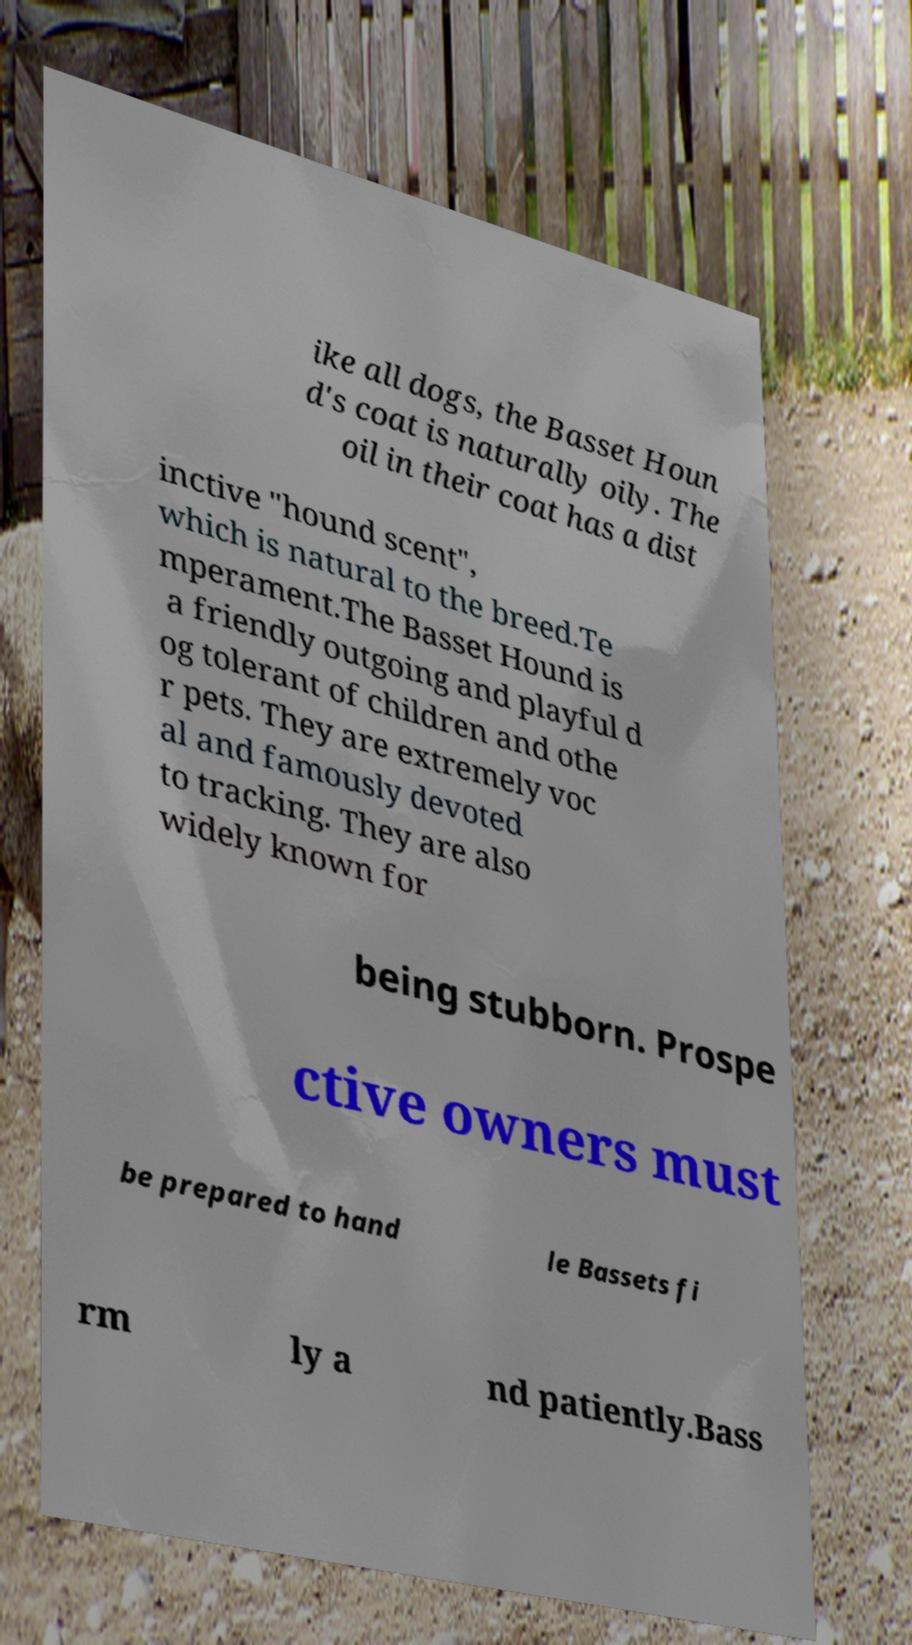There's text embedded in this image that I need extracted. Can you transcribe it verbatim? ike all dogs, the Basset Houn d's coat is naturally oily. The oil in their coat has a dist inctive "hound scent", which is natural to the breed.Te mperament.The Basset Hound is a friendly outgoing and playful d og tolerant of children and othe r pets. They are extremely voc al and famously devoted to tracking. They are also widely known for being stubborn. Prospe ctive owners must be prepared to hand le Bassets fi rm ly a nd patiently.Bass 